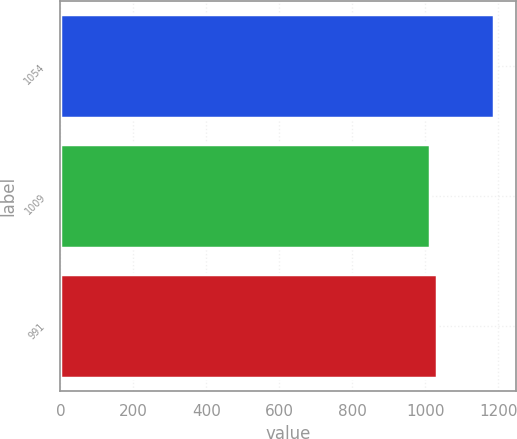<chart> <loc_0><loc_0><loc_500><loc_500><bar_chart><fcel>1054<fcel>1009<fcel>991<nl><fcel>1189<fcel>1014<fcel>1031.5<nl></chart> 